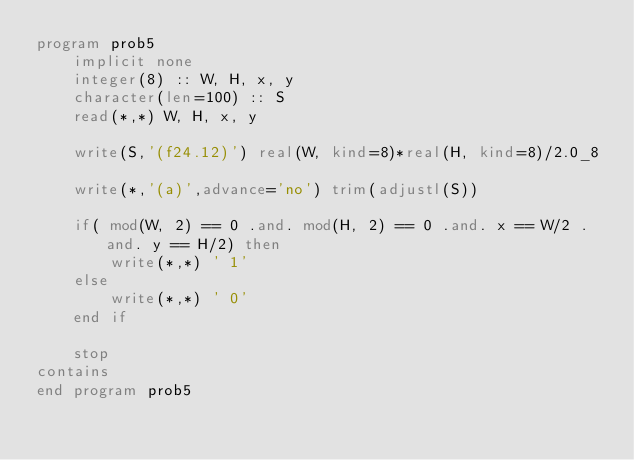Convert code to text. <code><loc_0><loc_0><loc_500><loc_500><_FORTRAN_>program prob5
    implicit none
    integer(8) :: W, H, x, y
    character(len=100) :: S
    read(*,*) W, H, x, y

    write(S,'(f24.12)') real(W, kind=8)*real(H, kind=8)/2.0_8

    write(*,'(a)',advance='no') trim(adjustl(S))

    if( mod(W, 2) == 0 .and. mod(H, 2) == 0 .and. x == W/2 .and. y == H/2) then
        write(*,*) ' 1'
    else
        write(*,*) ' 0'
    end if

    stop
contains
end program prob5</code> 